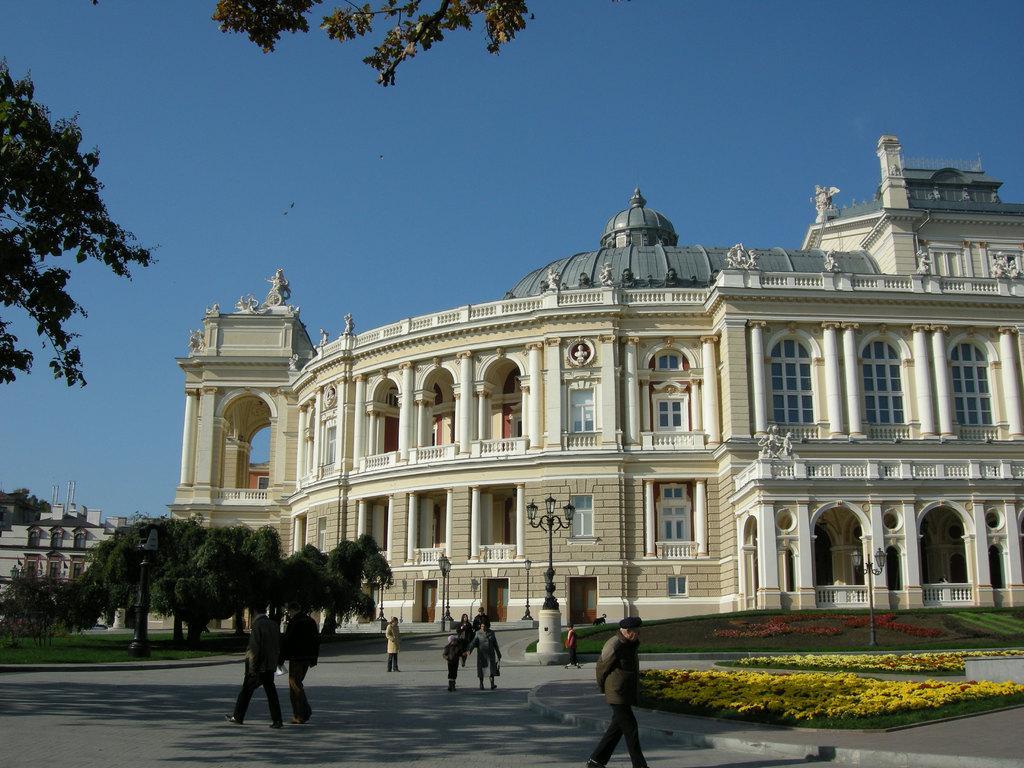How would you summarize this image in a sentence or two? In this image I can see a building in front of building I can see street light pole and grass and flowers visible on grass and lights and persons walking on road visible and on the left side I can see buildings and trees and at the top I can see the sky 